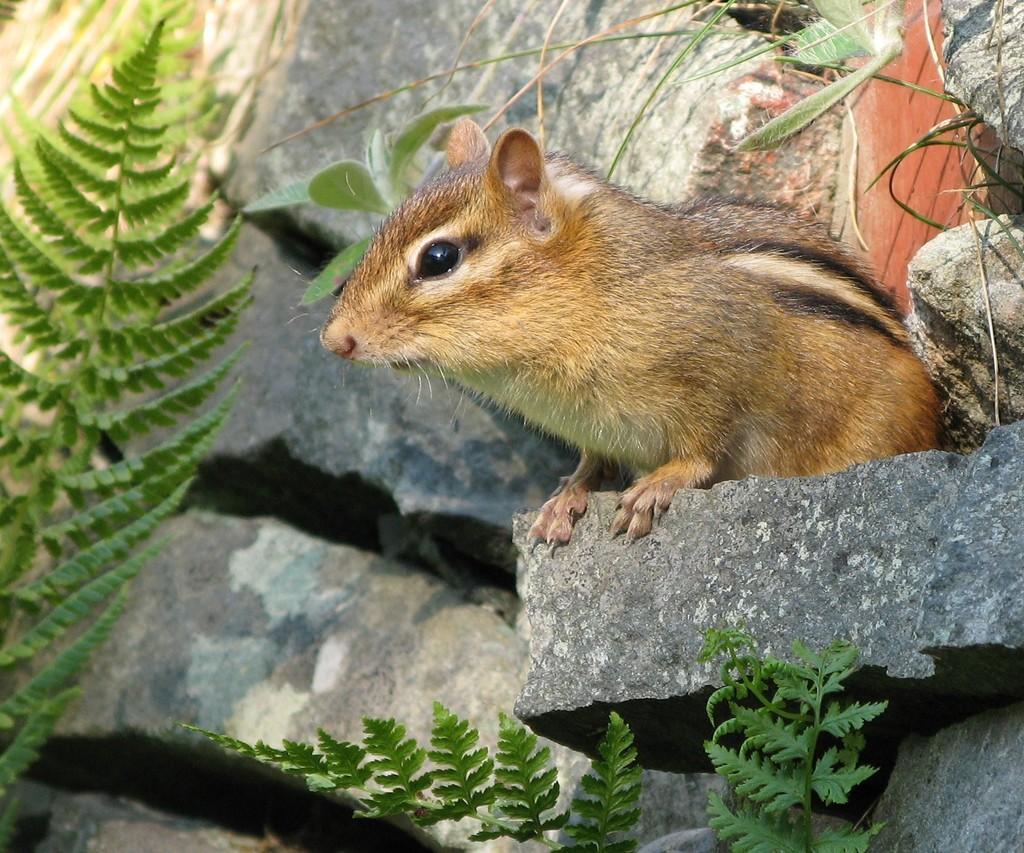How would you summarize this image in a sentence or two? In the middle I can see a mouse on a stone, plants and rocks. This image is taken may be during a day. 